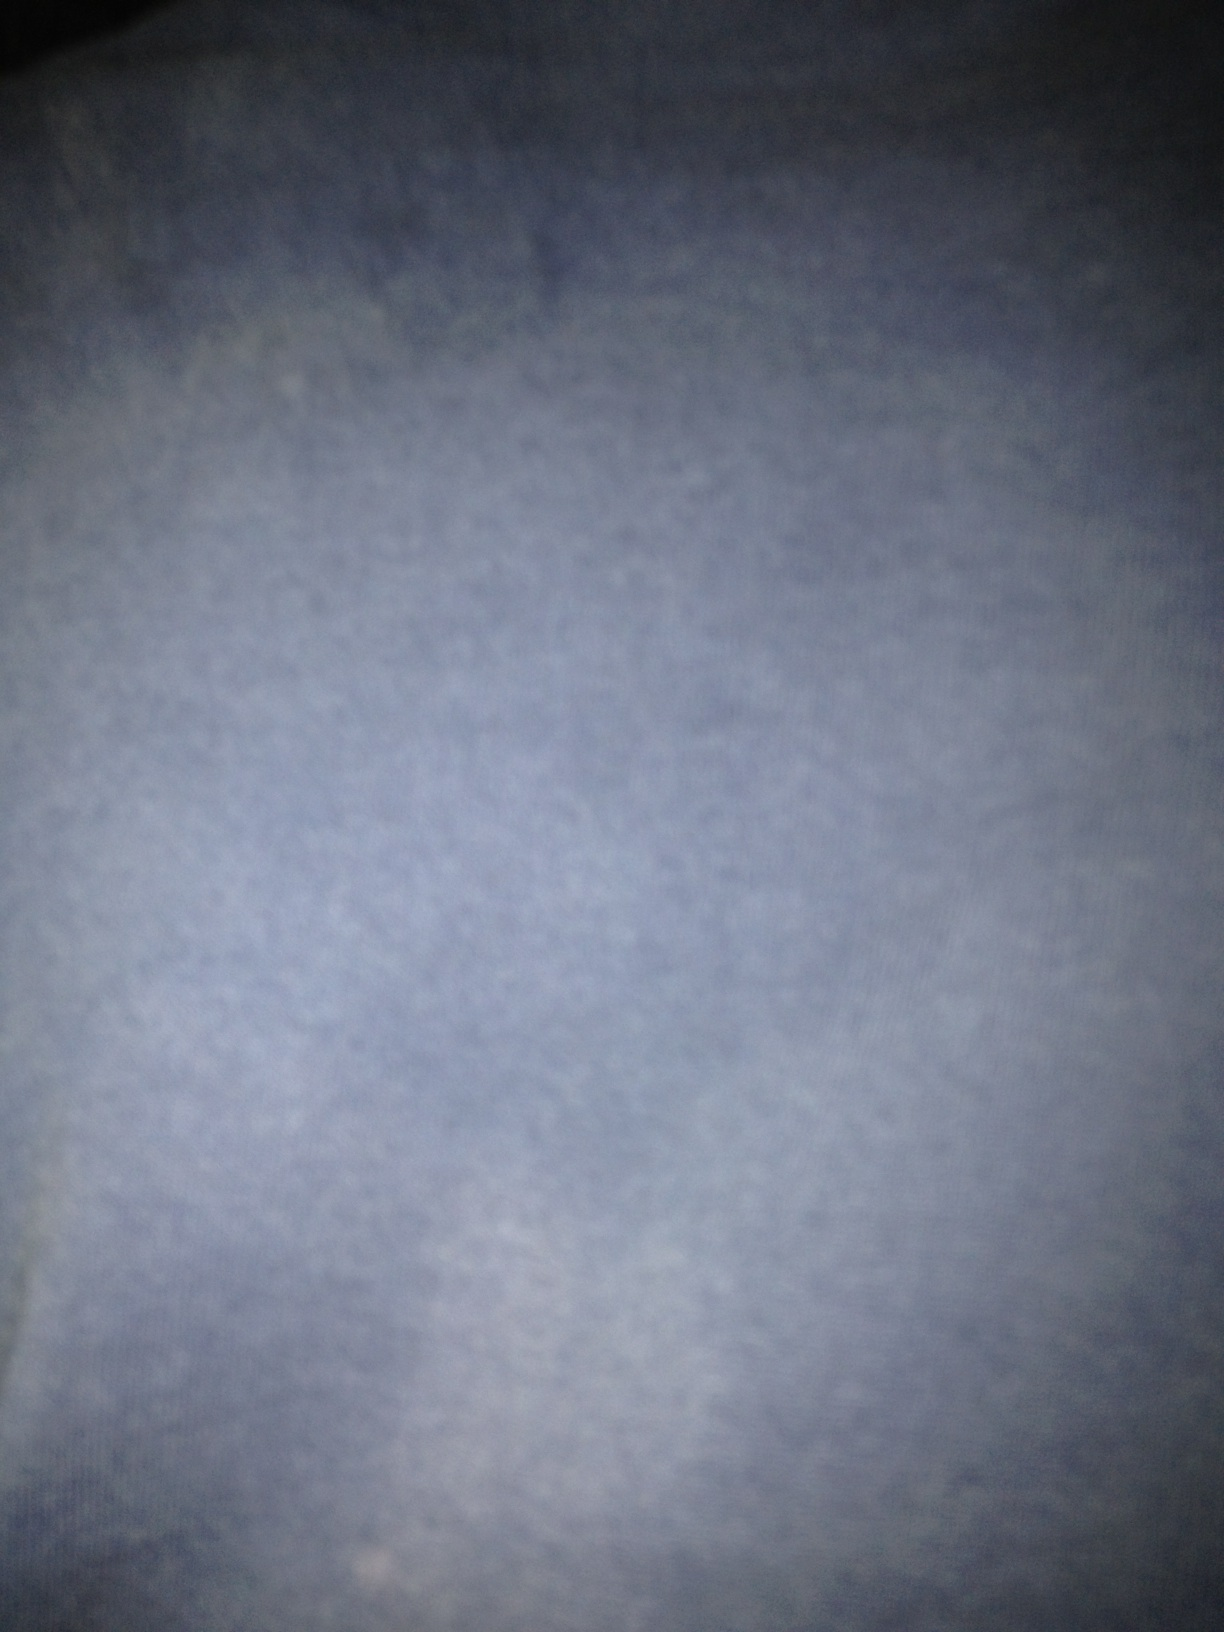What color is this shirt? Due to the extreme blurriness of the image, it's impossible to visually determine any specifics about a shirt, including its color. 